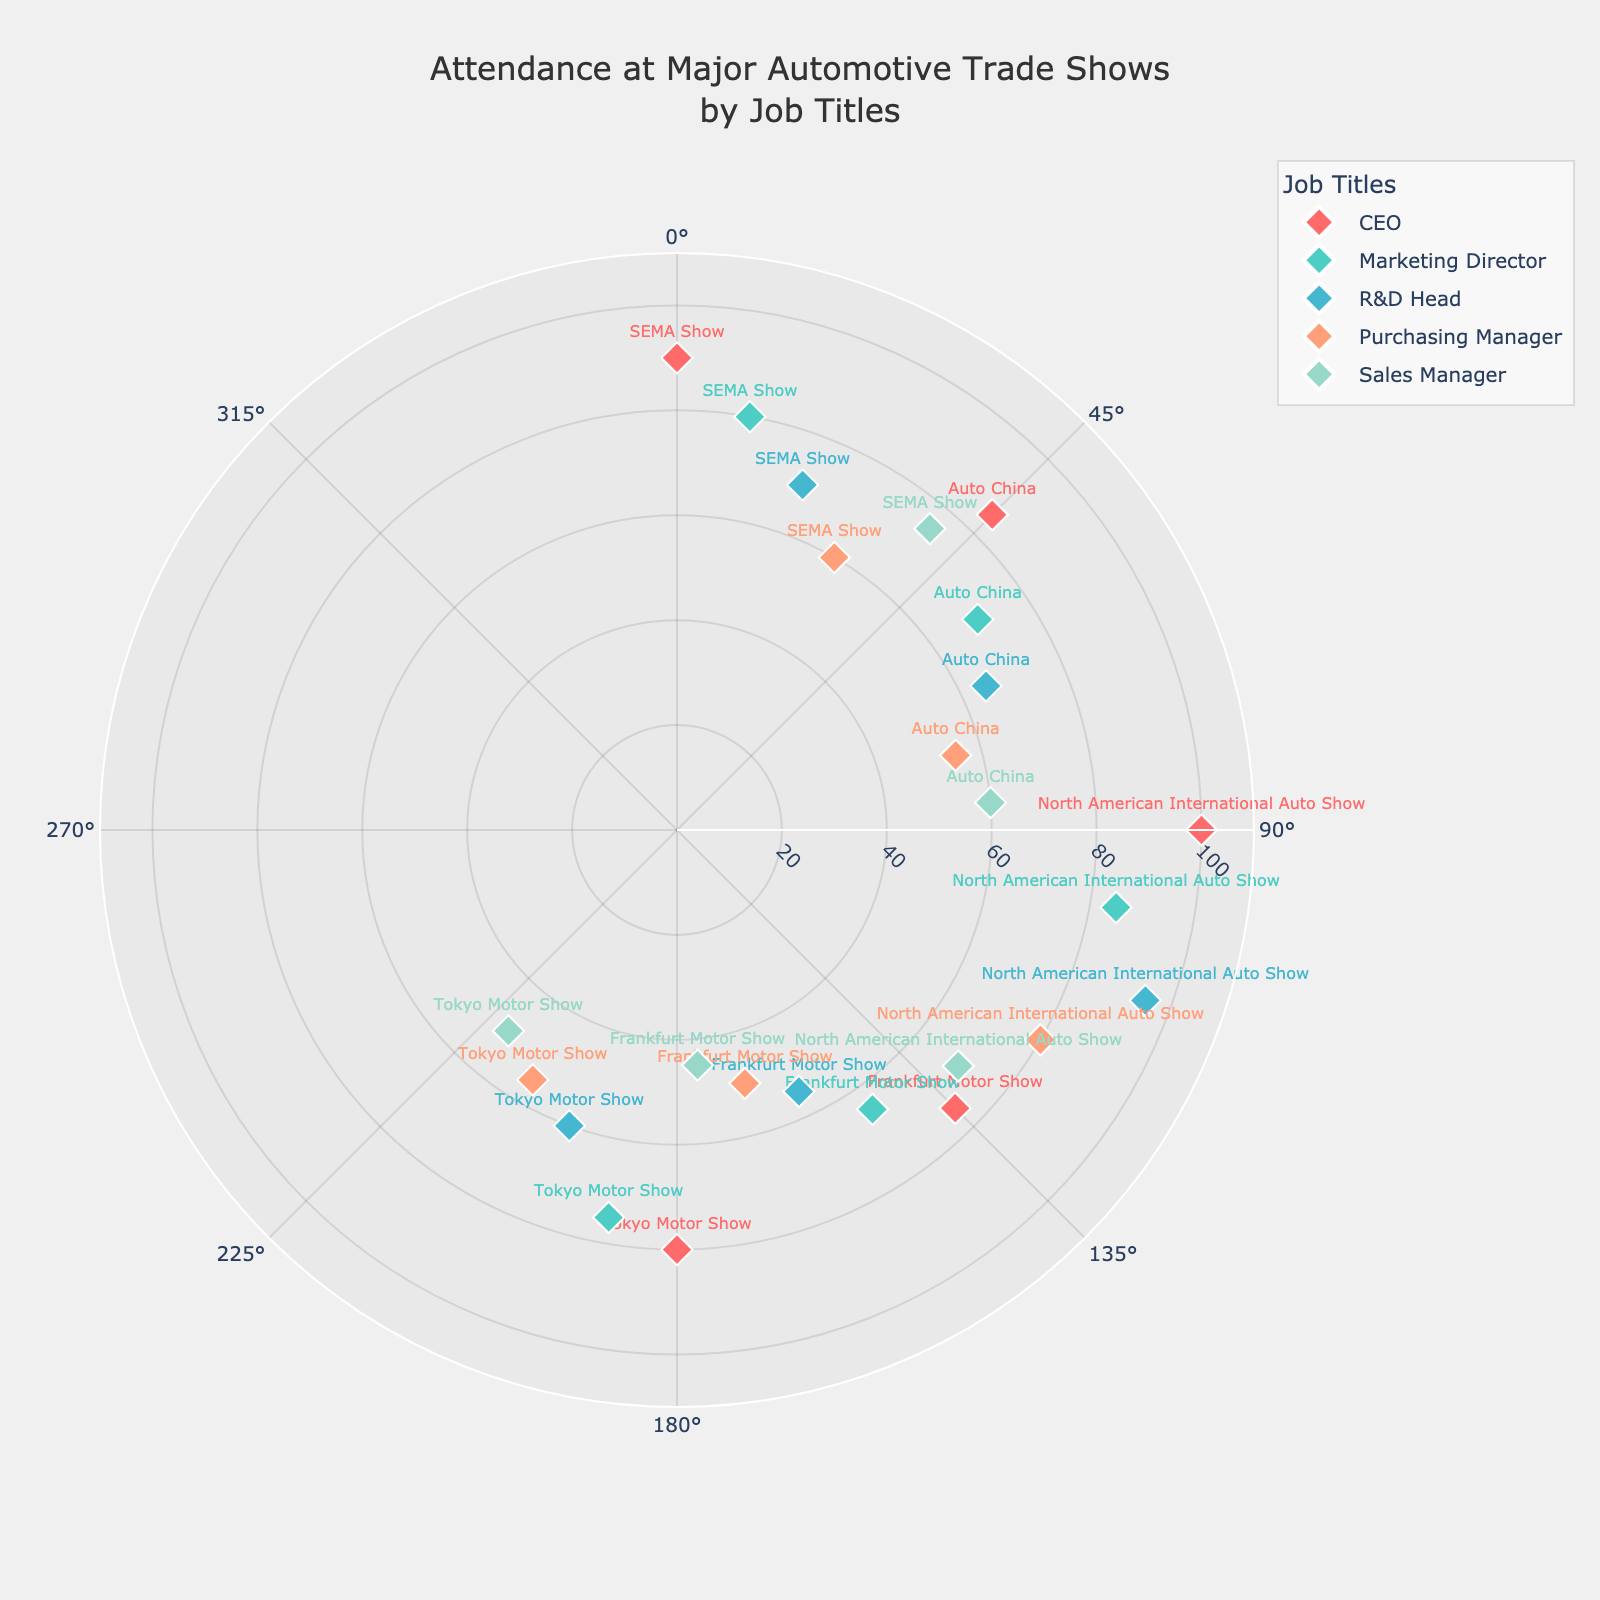How many trade shows are listed in the chart? By observing the number of unique trade shows mentioned in the plot, we can count SEMA Show, Auto China, North American International Auto Show, Frankfurt Motor Show, and Tokyo Motor Show.
Answer: 5 Which job title has the highest attendance at the North American International Auto Show? In the polar scatter plot, at the angle corresponding to the North American International Auto Show (90 degrees), the distance from the center is the highest for the CEO, indicating their attendance is the highest.
Answer: CEO Which trade show had the lowest attendance by Sales Manager, and what is the attendance number? By looking at the data points for the Sales Manager and comparing their distances from the center, we find Frankfurt Motor Show (175 degrees) with the lowest attendance of 45.
Answer: Frankfurt Motor Show, 45 Compare the attendance of the R&D Head and the Marketing Director at the SEMA Show. Who attended more? At the angle corresponding to the SEMA Show (0 degrees for CEO, 10 degrees for Marketing Director, and 20 degrees for R&D Head), the distance from the center for Marketing Director is 80, while for R&D Head it is 70.
Answer: Marketing Director Based on the plot, which job title has the most uniform attendance across all the trade shows? Looking at the distances of each job title from the center across different angles (trade shows), the CEOs have relatively uniform attendance with values of 90, 85, 100, 75, and 80.
Answer: CEO At which trade show did the Purchasing Manager record an attendance of 60? By checking the data points for Purchasing Manager with an attendance distance of 60, it can be seen at the SEMA Show (30 degrees).
Answer: SEMA Show What is the average attendance for the Sales Manager across all trade shows? Sales Manager's attendances are 75, 60, 70, 45, and 50. Sum these values to get 300, then divide by the number of trade shows (5): 300/5 = 60
Answer: 60 Which job titles show a decreasing trend in attendance from SEMA Show to Tokyo Motor Show? By following the angle and the corresponding attendance values, both Purchasing Manager (60 to 55), and Sales Manager (75 to 50) show a general decreasing trend from SEMA Show to Tokyo Motor Show.
Answer: Purchasing Manager, Sales Manager Among all the job titles, who had the highest individual attendance at any trade show? The highest attendance is at the North American International Auto Show (90 degrees), where the CEO's distance from the center is 100.
Answer: CEO 